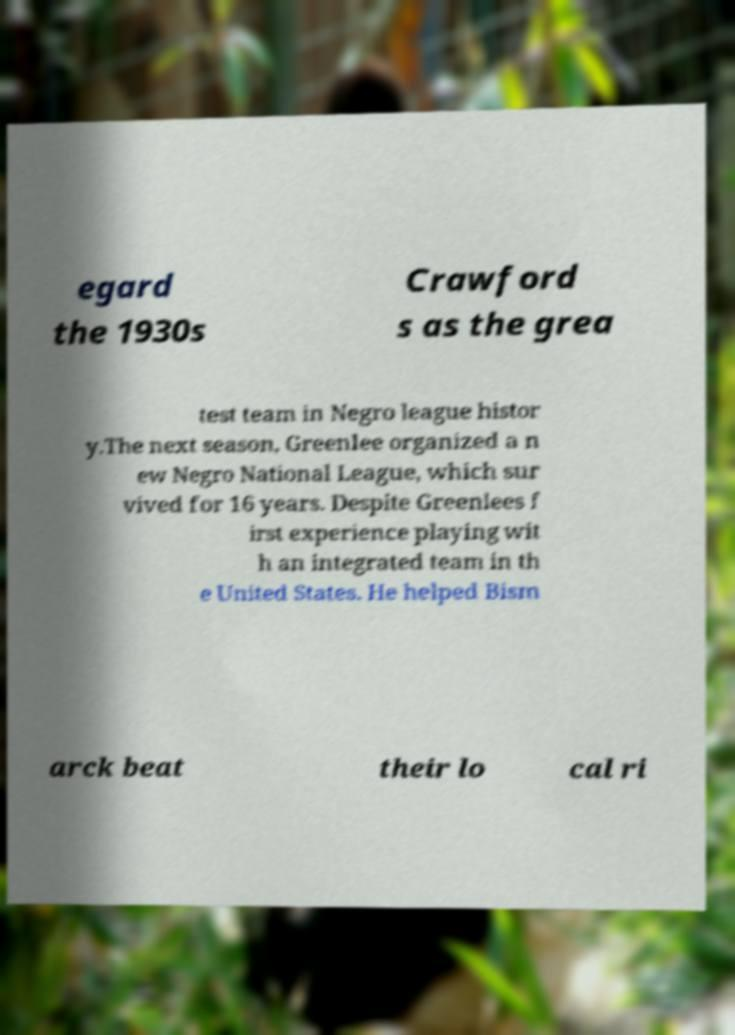Could you extract and type out the text from this image? egard the 1930s Crawford s as the grea test team in Negro league histor y.The next season, Greenlee organized a n ew Negro National League, which sur vived for 16 years. Despite Greenlees f irst experience playing wit h an integrated team in th e United States. He helped Bism arck beat their lo cal ri 